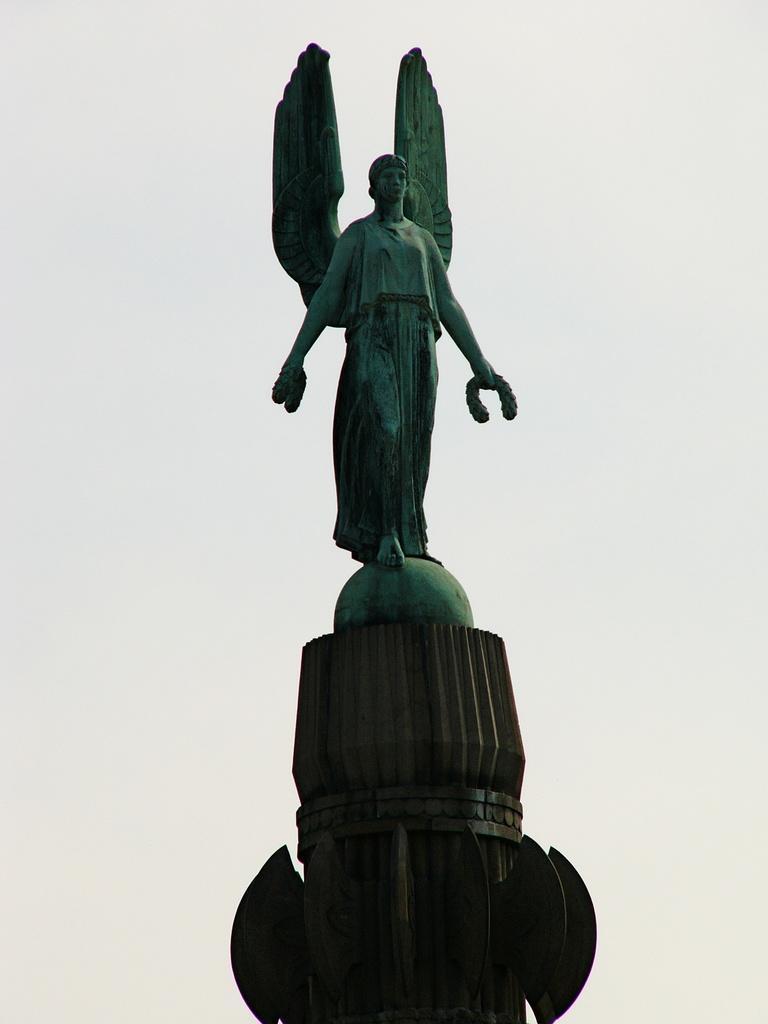How would you summarize this image in a sentence or two? In the center of the image there is a statue. 